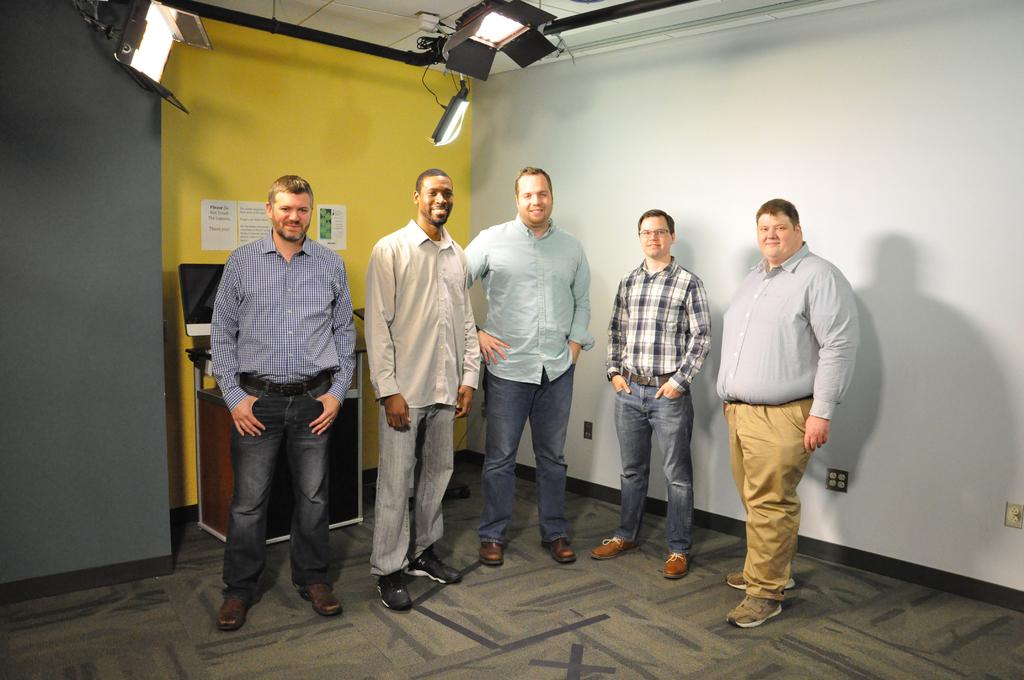What is the main subject of the image? There is a group of people standing on the floor. Can you describe any objects or features in the background? There is a screen placed on a table and papers on the wall in the background. What else can be seen in the background? There are lights visible in the background. What type of vest is the person in the image wearing? There is no vest visible in the image; the people are not wearing any clothing mentioned in the facts. 